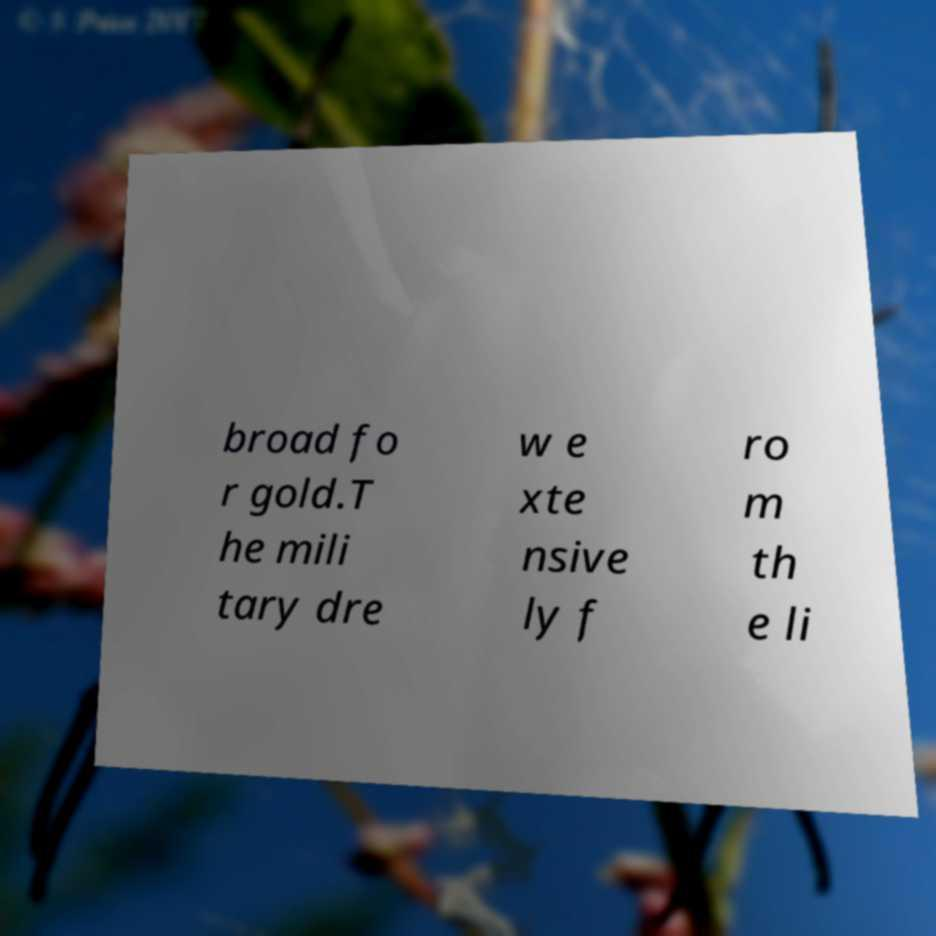Please read and relay the text visible in this image. What does it say? broad fo r gold.T he mili tary dre w e xte nsive ly f ro m th e li 